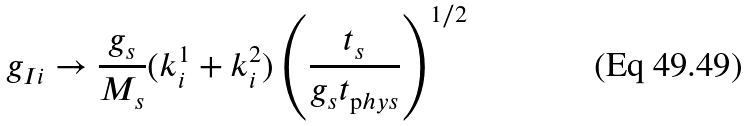<formula> <loc_0><loc_0><loc_500><loc_500>g _ { I i } \rightarrow \frac { g _ { s } } { M _ { s } } ( k ^ { 1 } _ { i } + k ^ { 2 } _ { i } ) \left ( \frac { t _ { s } } { g _ { s } t _ { \mathrm p h y s } } \right ) ^ { 1 / 2 }</formula> 